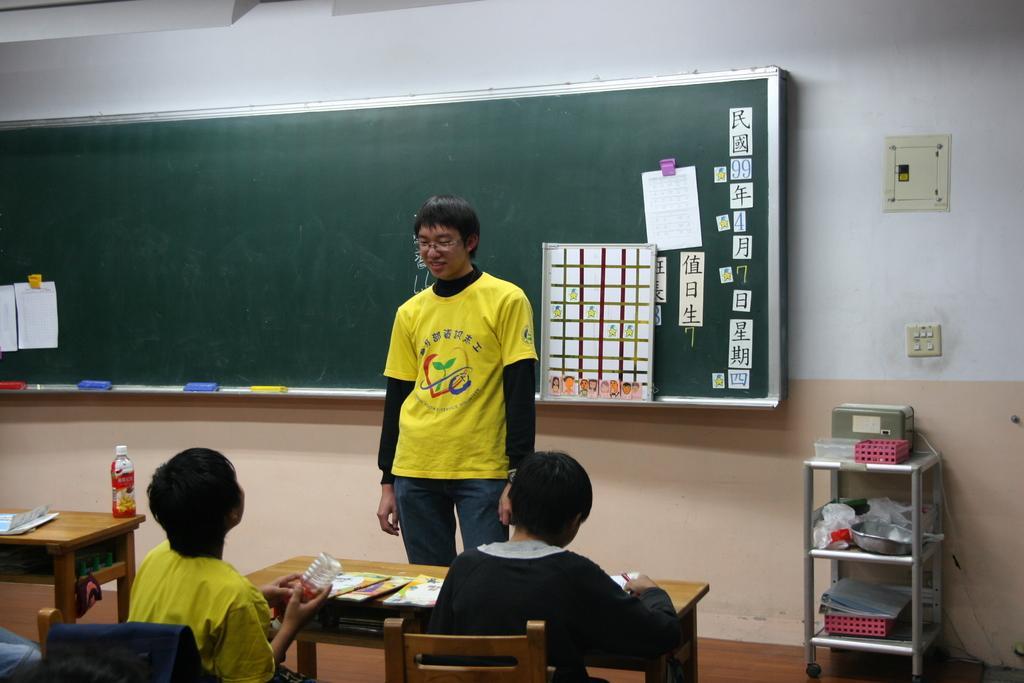Could you give a brief overview of what you see in this image? In the image we can see there is a person who is standing and in front of him there are people who are sitting on bench and at the back of the man there is board. 